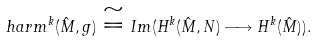<formula> <loc_0><loc_0><loc_500><loc_500>\ h a r m ^ { k } ( \hat { M } , g ) \cong I m ( H ^ { k } ( \hat { M } , N ) \longrightarrow H ^ { k } ( \hat { M } ) ) .</formula> 